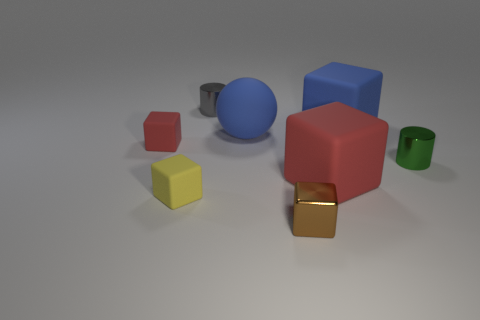Subtract all tiny shiny blocks. How many blocks are left? 4 Subtract all yellow blocks. How many blocks are left? 4 Subtract 2 cubes. How many cubes are left? 3 Subtract all purple blocks. Subtract all gray spheres. How many blocks are left? 5 Add 1 tiny red objects. How many objects exist? 9 Subtract all blocks. How many objects are left? 3 Subtract all big red cubes. Subtract all tiny red shiny blocks. How many objects are left? 7 Add 2 big matte blocks. How many big matte blocks are left? 4 Add 1 large purple objects. How many large purple objects exist? 1 Subtract 0 green spheres. How many objects are left? 8 